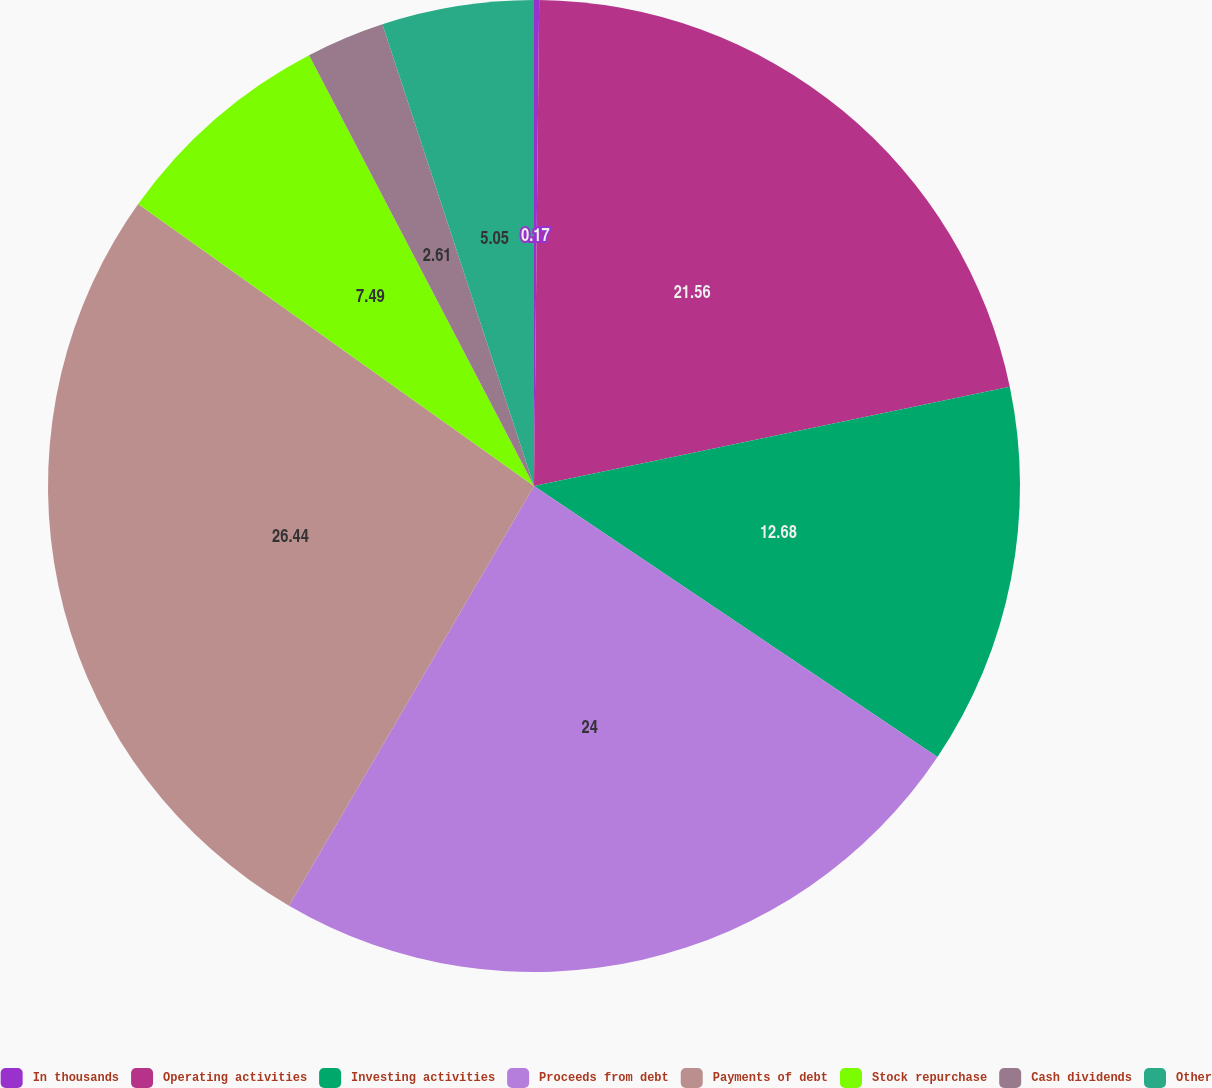<chart> <loc_0><loc_0><loc_500><loc_500><pie_chart><fcel>In thousands<fcel>Operating activities<fcel>Investing activities<fcel>Proceeds from debt<fcel>Payments of debt<fcel>Stock repurchase<fcel>Cash dividends<fcel>Other<nl><fcel>0.17%<fcel>21.56%<fcel>12.68%<fcel>24.0%<fcel>26.44%<fcel>7.49%<fcel>2.61%<fcel>5.05%<nl></chart> 